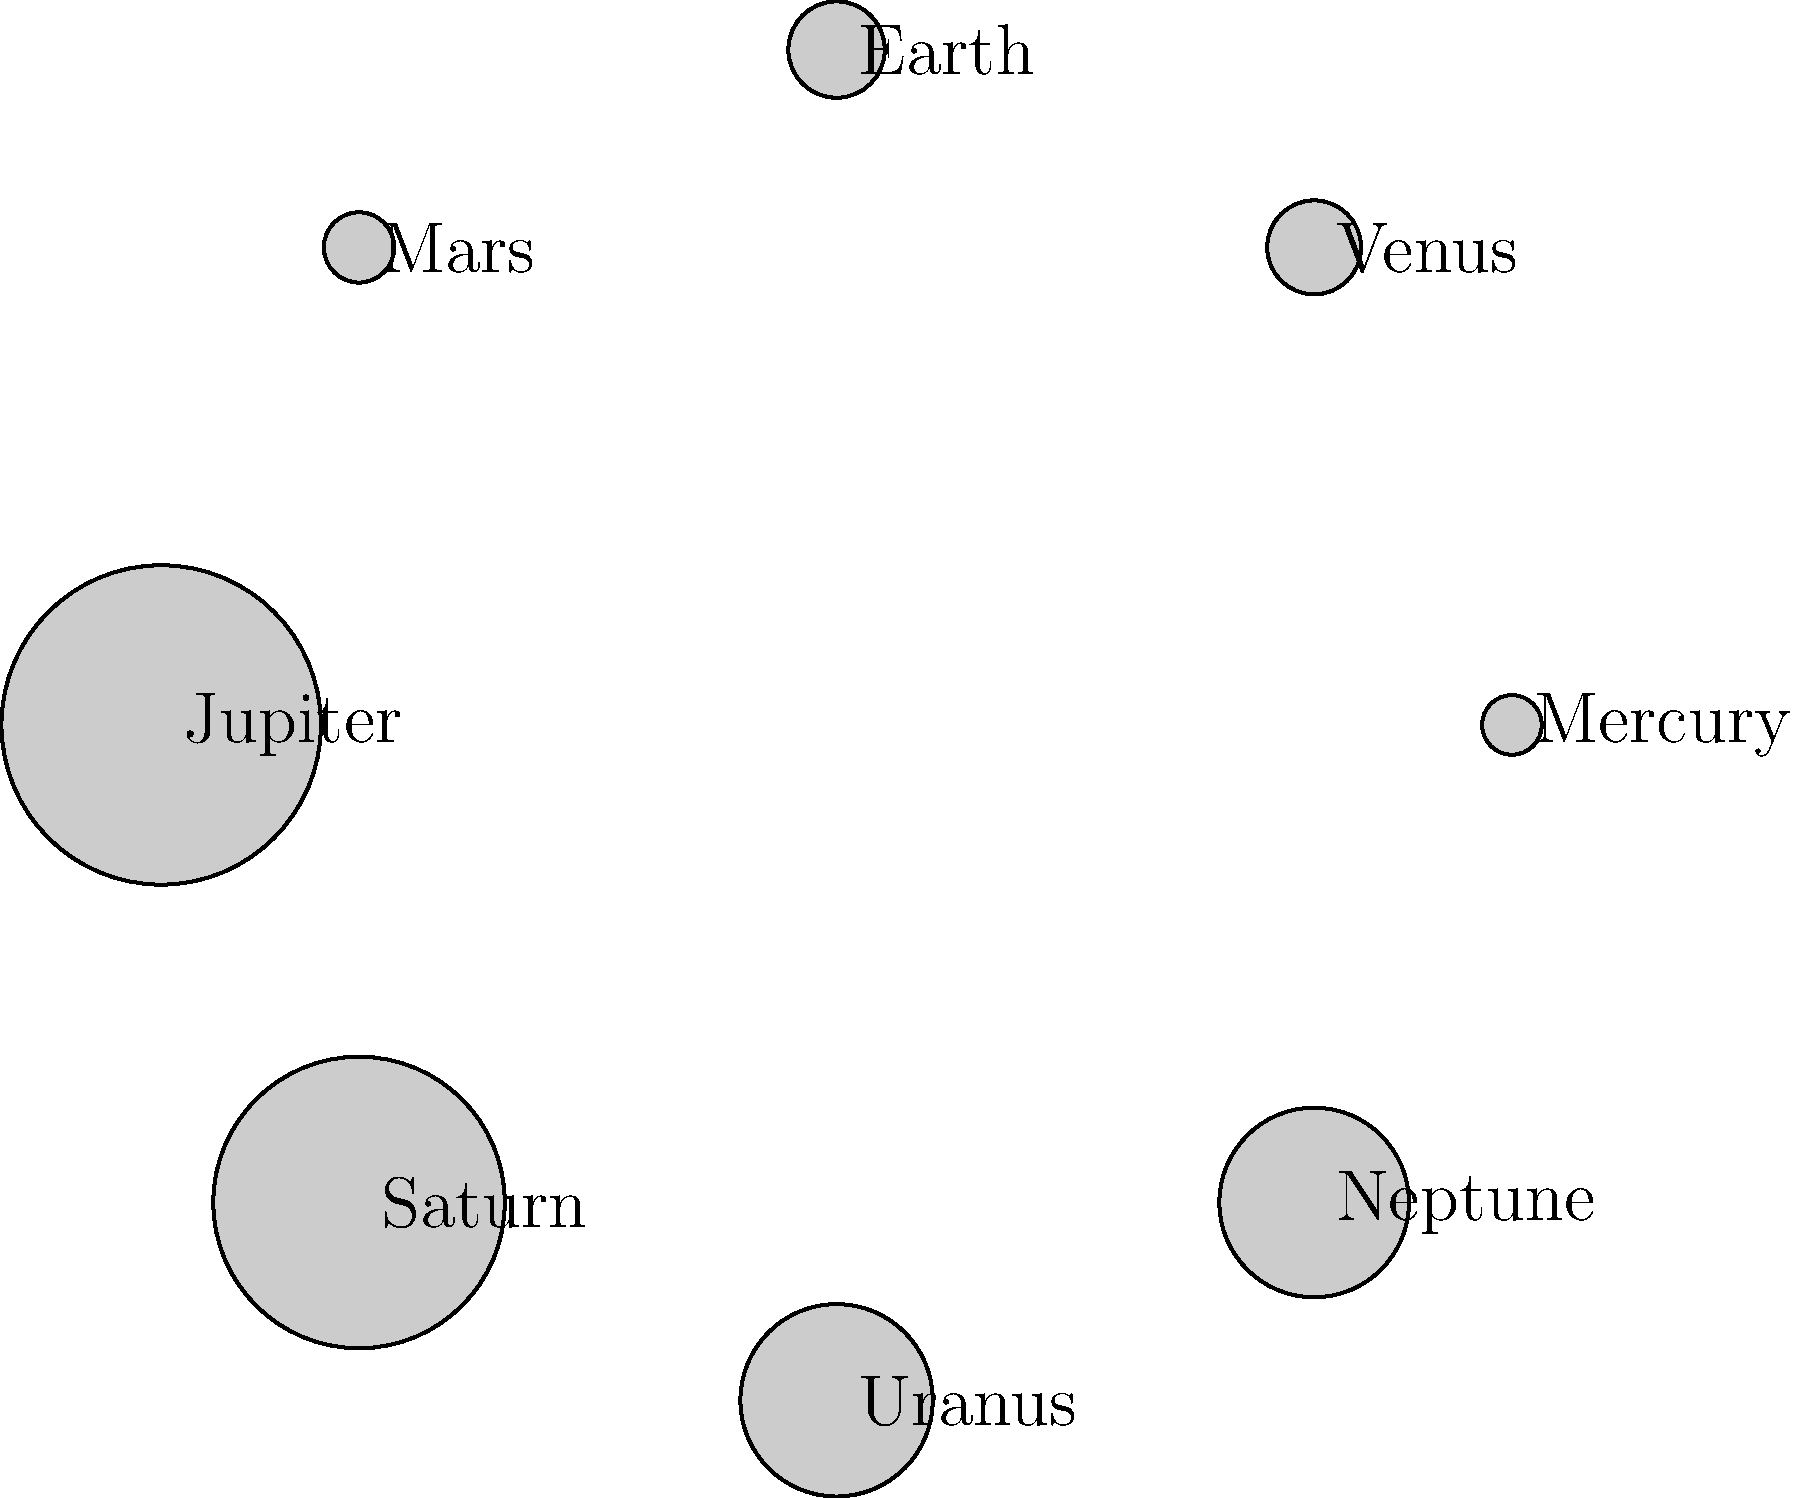In the diagram, planets are represented as circles with areas proportional to their actual sizes. If we consider the binary representation of planet sizes, which planet's size would require the most bits to represent accurately, assuming we use the minimum number of bits needed for each planet? To solve this problem, we need to follow these steps:

1) The area of each circle is proportional to the actual size (diameter) of the planet. The area of a circle is $\pi r^2$, where $r$ is the radius.

2) The diameters of the planets in thousands of kilometers are:
   Mercury: 4.879
   Venus: 12.104
   Earth: 12.742
   Mars: 6.779
   Jupiter: 139.820
   Saturn: 116.460
   Uranus: 50.724
   Neptune: 49.244

3) To represent these numbers in binary, we need to consider the largest number, which is Jupiter at 139.820.

4) To calculate the number of bits needed, we use the formula:
   $\text{bits} = \lceil \log_2(n) \rceil$, where $n$ is the number to represent.

5) For Jupiter: $\lceil \log_2(139820) \rceil = \lceil 17.093 \rceil = 18$ bits

6) We can verify that 18 bits is indeed the maximum:
   $2^{17} = 131072 < 139820 < 262144 = 2^{18}$

7) No other planet requires more than 18 bits to represent its size.

Therefore, Jupiter's size would require the most bits to represent accurately.
Answer: Jupiter 